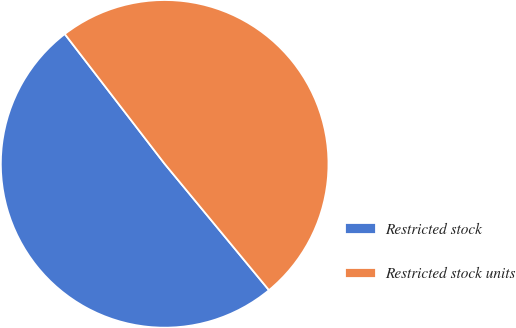<chart> <loc_0><loc_0><loc_500><loc_500><pie_chart><fcel>Restricted stock<fcel>Restricted stock units<nl><fcel>50.55%<fcel>49.45%<nl></chart> 